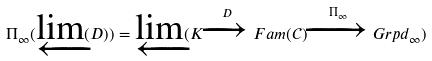<formula> <loc_0><loc_0><loc_500><loc_500>\Pi _ { \infty } ( \varprojlim ( D ) ) = \varprojlim ( K \xrightarrow { D } F a m ( \mathcal { C } ) \xrightarrow { \Pi _ { \infty } } G r p d _ { \infty } )</formula> 